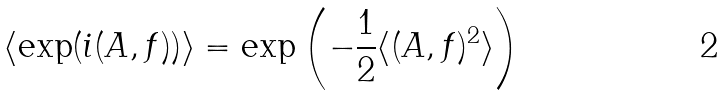<formula> <loc_0><loc_0><loc_500><loc_500>\langle \exp ( i ( { A } , { f } ) ) \rangle = \exp \left ( - \frac { 1 } { 2 } \langle ( { A } , { f } ) ^ { 2 } \rangle \right )</formula> 